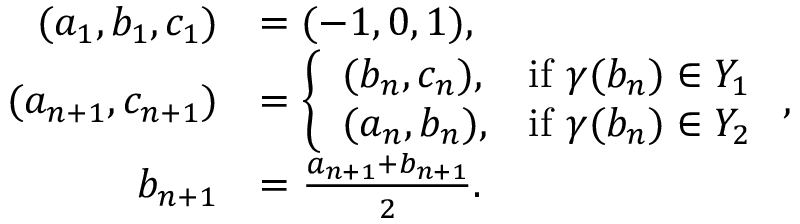<formula> <loc_0><loc_0><loc_500><loc_500>\begin{array} { r l } { ( a _ { 1 } , b _ { 1 } , c _ { 1 } ) } & { = ( - 1 , 0 , 1 ) , } \\ { ( a _ { n + 1 } , c _ { n + 1 } ) } & { = \left \{ \begin{array} { l l } { ( b _ { n } , c _ { n } ) , } & { i f \gamma ( b _ { n } ) \in Y _ { 1 } } \\ { ( a _ { n } , b _ { n } ) , } & { i f \gamma ( b _ { n } ) \in Y _ { 2 } } \end{array} , } \\ { b _ { n + 1 } } & { = \frac { a _ { n + 1 } + b _ { n + 1 } } { 2 } . } \end{array}</formula> 